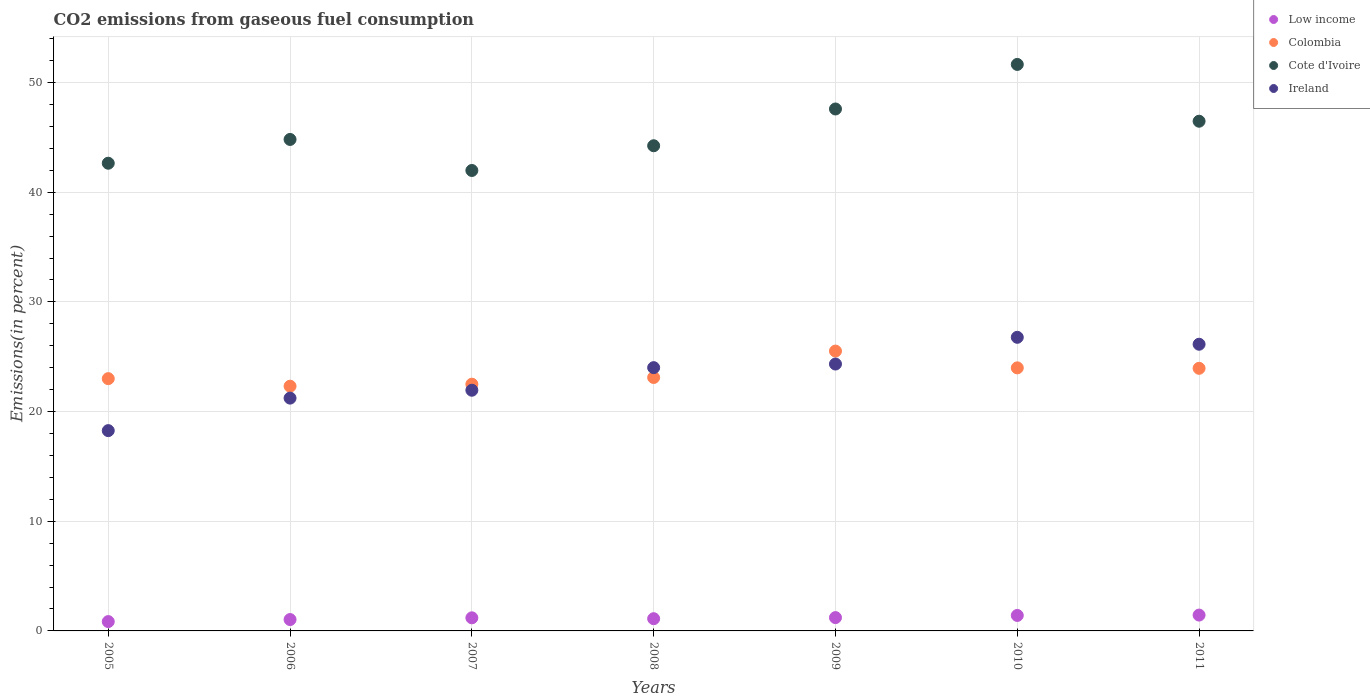How many different coloured dotlines are there?
Keep it short and to the point. 4. What is the total CO2 emitted in Cote d'Ivoire in 2007?
Keep it short and to the point. 41.98. Across all years, what is the maximum total CO2 emitted in Low income?
Make the answer very short. 1.44. Across all years, what is the minimum total CO2 emitted in Low income?
Your answer should be compact. 0.85. What is the total total CO2 emitted in Cote d'Ivoire in the graph?
Offer a terse response. 319.39. What is the difference between the total CO2 emitted in Low income in 2005 and that in 2011?
Your answer should be very brief. -0.59. What is the difference between the total CO2 emitted in Cote d'Ivoire in 2008 and the total CO2 emitted in Ireland in 2007?
Keep it short and to the point. 22.29. What is the average total CO2 emitted in Low income per year?
Keep it short and to the point. 1.18. In the year 2005, what is the difference between the total CO2 emitted in Cote d'Ivoire and total CO2 emitted in Ireland?
Provide a succinct answer. 24.38. What is the ratio of the total CO2 emitted in Low income in 2009 to that in 2011?
Your answer should be compact. 0.84. What is the difference between the highest and the second highest total CO2 emitted in Ireland?
Give a very brief answer. 0.63. What is the difference between the highest and the lowest total CO2 emitted in Cote d'Ivoire?
Your response must be concise. 9.67. Is it the case that in every year, the sum of the total CO2 emitted in Cote d'Ivoire and total CO2 emitted in Colombia  is greater than the sum of total CO2 emitted in Low income and total CO2 emitted in Ireland?
Offer a very short reply. Yes. Is it the case that in every year, the sum of the total CO2 emitted in Cote d'Ivoire and total CO2 emitted in Colombia  is greater than the total CO2 emitted in Low income?
Keep it short and to the point. Yes. Does the total CO2 emitted in Ireland monotonically increase over the years?
Make the answer very short. No. Is the total CO2 emitted in Colombia strictly greater than the total CO2 emitted in Ireland over the years?
Your answer should be compact. No. Is the total CO2 emitted in Colombia strictly less than the total CO2 emitted in Cote d'Ivoire over the years?
Offer a terse response. Yes. How many years are there in the graph?
Offer a terse response. 7. Does the graph contain grids?
Offer a terse response. Yes. How many legend labels are there?
Your answer should be compact. 4. How are the legend labels stacked?
Your answer should be compact. Vertical. What is the title of the graph?
Give a very brief answer. CO2 emissions from gaseous fuel consumption. What is the label or title of the X-axis?
Provide a short and direct response. Years. What is the label or title of the Y-axis?
Offer a terse response. Emissions(in percent). What is the Emissions(in percent) in Low income in 2005?
Offer a very short reply. 0.85. What is the Emissions(in percent) in Colombia in 2005?
Your response must be concise. 23. What is the Emissions(in percent) of Cote d'Ivoire in 2005?
Your response must be concise. 42.64. What is the Emissions(in percent) in Ireland in 2005?
Keep it short and to the point. 18.26. What is the Emissions(in percent) in Low income in 2006?
Provide a short and direct response. 1.04. What is the Emissions(in percent) of Colombia in 2006?
Provide a succinct answer. 22.31. What is the Emissions(in percent) in Cote d'Ivoire in 2006?
Offer a terse response. 44.81. What is the Emissions(in percent) of Ireland in 2006?
Offer a terse response. 21.23. What is the Emissions(in percent) of Low income in 2007?
Make the answer very short. 1.19. What is the Emissions(in percent) of Colombia in 2007?
Make the answer very short. 22.5. What is the Emissions(in percent) in Cote d'Ivoire in 2007?
Offer a very short reply. 41.98. What is the Emissions(in percent) in Ireland in 2007?
Give a very brief answer. 21.95. What is the Emissions(in percent) of Low income in 2008?
Give a very brief answer. 1.11. What is the Emissions(in percent) in Colombia in 2008?
Your response must be concise. 23.11. What is the Emissions(in percent) in Cote d'Ivoire in 2008?
Provide a succinct answer. 44.24. What is the Emissions(in percent) in Ireland in 2008?
Your response must be concise. 24.01. What is the Emissions(in percent) of Low income in 2009?
Offer a terse response. 1.21. What is the Emissions(in percent) of Colombia in 2009?
Provide a succinct answer. 25.52. What is the Emissions(in percent) of Cote d'Ivoire in 2009?
Make the answer very short. 47.59. What is the Emissions(in percent) of Ireland in 2009?
Provide a succinct answer. 24.33. What is the Emissions(in percent) in Low income in 2010?
Offer a very short reply. 1.41. What is the Emissions(in percent) in Colombia in 2010?
Make the answer very short. 23.99. What is the Emissions(in percent) of Cote d'Ivoire in 2010?
Make the answer very short. 51.65. What is the Emissions(in percent) of Ireland in 2010?
Give a very brief answer. 26.77. What is the Emissions(in percent) of Low income in 2011?
Your answer should be compact. 1.44. What is the Emissions(in percent) of Colombia in 2011?
Make the answer very short. 23.94. What is the Emissions(in percent) in Cote d'Ivoire in 2011?
Give a very brief answer. 46.47. What is the Emissions(in percent) of Ireland in 2011?
Keep it short and to the point. 26.14. Across all years, what is the maximum Emissions(in percent) of Low income?
Make the answer very short. 1.44. Across all years, what is the maximum Emissions(in percent) of Colombia?
Your response must be concise. 25.52. Across all years, what is the maximum Emissions(in percent) in Cote d'Ivoire?
Your response must be concise. 51.65. Across all years, what is the maximum Emissions(in percent) of Ireland?
Your answer should be very brief. 26.77. Across all years, what is the minimum Emissions(in percent) of Low income?
Provide a short and direct response. 0.85. Across all years, what is the minimum Emissions(in percent) in Colombia?
Make the answer very short. 22.31. Across all years, what is the minimum Emissions(in percent) of Cote d'Ivoire?
Give a very brief answer. 41.98. Across all years, what is the minimum Emissions(in percent) of Ireland?
Provide a short and direct response. 18.26. What is the total Emissions(in percent) in Low income in the graph?
Your answer should be compact. 8.27. What is the total Emissions(in percent) of Colombia in the graph?
Your response must be concise. 164.37. What is the total Emissions(in percent) in Cote d'Ivoire in the graph?
Offer a terse response. 319.39. What is the total Emissions(in percent) of Ireland in the graph?
Provide a short and direct response. 162.68. What is the difference between the Emissions(in percent) of Low income in 2005 and that in 2006?
Your answer should be very brief. -0.19. What is the difference between the Emissions(in percent) in Colombia in 2005 and that in 2006?
Provide a succinct answer. 0.69. What is the difference between the Emissions(in percent) in Cote d'Ivoire in 2005 and that in 2006?
Give a very brief answer. -2.17. What is the difference between the Emissions(in percent) of Ireland in 2005 and that in 2006?
Your response must be concise. -2.96. What is the difference between the Emissions(in percent) of Low income in 2005 and that in 2007?
Provide a succinct answer. -0.34. What is the difference between the Emissions(in percent) in Colombia in 2005 and that in 2007?
Offer a terse response. 0.51. What is the difference between the Emissions(in percent) of Cote d'Ivoire in 2005 and that in 2007?
Provide a short and direct response. 0.66. What is the difference between the Emissions(in percent) in Ireland in 2005 and that in 2007?
Provide a succinct answer. -3.68. What is the difference between the Emissions(in percent) in Low income in 2005 and that in 2008?
Your answer should be compact. -0.26. What is the difference between the Emissions(in percent) of Colombia in 2005 and that in 2008?
Make the answer very short. -0.11. What is the difference between the Emissions(in percent) in Cote d'Ivoire in 2005 and that in 2008?
Offer a very short reply. -1.59. What is the difference between the Emissions(in percent) in Ireland in 2005 and that in 2008?
Keep it short and to the point. -5.74. What is the difference between the Emissions(in percent) of Low income in 2005 and that in 2009?
Make the answer very short. -0.36. What is the difference between the Emissions(in percent) of Colombia in 2005 and that in 2009?
Your answer should be compact. -2.51. What is the difference between the Emissions(in percent) in Cote d'Ivoire in 2005 and that in 2009?
Your answer should be very brief. -4.95. What is the difference between the Emissions(in percent) of Ireland in 2005 and that in 2009?
Your answer should be very brief. -6.07. What is the difference between the Emissions(in percent) of Low income in 2005 and that in 2010?
Your answer should be very brief. -0.56. What is the difference between the Emissions(in percent) of Colombia in 2005 and that in 2010?
Your response must be concise. -0.98. What is the difference between the Emissions(in percent) in Cote d'Ivoire in 2005 and that in 2010?
Offer a very short reply. -9.01. What is the difference between the Emissions(in percent) in Ireland in 2005 and that in 2010?
Provide a succinct answer. -8.51. What is the difference between the Emissions(in percent) of Low income in 2005 and that in 2011?
Your answer should be compact. -0.59. What is the difference between the Emissions(in percent) in Colombia in 2005 and that in 2011?
Your response must be concise. -0.94. What is the difference between the Emissions(in percent) in Cote d'Ivoire in 2005 and that in 2011?
Your response must be concise. -3.83. What is the difference between the Emissions(in percent) in Ireland in 2005 and that in 2011?
Your answer should be very brief. -7.88. What is the difference between the Emissions(in percent) of Low income in 2006 and that in 2007?
Offer a terse response. -0.16. What is the difference between the Emissions(in percent) of Colombia in 2006 and that in 2007?
Offer a very short reply. -0.18. What is the difference between the Emissions(in percent) of Cote d'Ivoire in 2006 and that in 2007?
Keep it short and to the point. 2.83. What is the difference between the Emissions(in percent) in Ireland in 2006 and that in 2007?
Keep it short and to the point. -0.72. What is the difference between the Emissions(in percent) of Low income in 2006 and that in 2008?
Your answer should be very brief. -0.08. What is the difference between the Emissions(in percent) in Colombia in 2006 and that in 2008?
Provide a short and direct response. -0.79. What is the difference between the Emissions(in percent) of Cote d'Ivoire in 2006 and that in 2008?
Offer a very short reply. 0.57. What is the difference between the Emissions(in percent) of Ireland in 2006 and that in 2008?
Offer a very short reply. -2.78. What is the difference between the Emissions(in percent) in Low income in 2006 and that in 2009?
Keep it short and to the point. -0.18. What is the difference between the Emissions(in percent) of Colombia in 2006 and that in 2009?
Make the answer very short. -3.2. What is the difference between the Emissions(in percent) in Cote d'Ivoire in 2006 and that in 2009?
Provide a succinct answer. -2.78. What is the difference between the Emissions(in percent) in Ireland in 2006 and that in 2009?
Provide a succinct answer. -3.11. What is the difference between the Emissions(in percent) in Low income in 2006 and that in 2010?
Give a very brief answer. -0.37. What is the difference between the Emissions(in percent) of Colombia in 2006 and that in 2010?
Offer a very short reply. -1.67. What is the difference between the Emissions(in percent) of Cote d'Ivoire in 2006 and that in 2010?
Provide a short and direct response. -6.84. What is the difference between the Emissions(in percent) of Ireland in 2006 and that in 2010?
Offer a terse response. -5.54. What is the difference between the Emissions(in percent) of Low income in 2006 and that in 2011?
Your response must be concise. -0.41. What is the difference between the Emissions(in percent) of Colombia in 2006 and that in 2011?
Your response must be concise. -1.63. What is the difference between the Emissions(in percent) in Cote d'Ivoire in 2006 and that in 2011?
Provide a short and direct response. -1.66. What is the difference between the Emissions(in percent) of Ireland in 2006 and that in 2011?
Your response must be concise. -4.91. What is the difference between the Emissions(in percent) of Low income in 2007 and that in 2008?
Give a very brief answer. 0.08. What is the difference between the Emissions(in percent) in Colombia in 2007 and that in 2008?
Give a very brief answer. -0.61. What is the difference between the Emissions(in percent) of Cote d'Ivoire in 2007 and that in 2008?
Your response must be concise. -2.25. What is the difference between the Emissions(in percent) of Ireland in 2007 and that in 2008?
Give a very brief answer. -2.06. What is the difference between the Emissions(in percent) of Low income in 2007 and that in 2009?
Your response must be concise. -0.02. What is the difference between the Emissions(in percent) of Colombia in 2007 and that in 2009?
Keep it short and to the point. -3.02. What is the difference between the Emissions(in percent) in Cote d'Ivoire in 2007 and that in 2009?
Provide a succinct answer. -5.61. What is the difference between the Emissions(in percent) of Ireland in 2007 and that in 2009?
Provide a short and direct response. -2.39. What is the difference between the Emissions(in percent) in Low income in 2007 and that in 2010?
Make the answer very short. -0.22. What is the difference between the Emissions(in percent) of Colombia in 2007 and that in 2010?
Your response must be concise. -1.49. What is the difference between the Emissions(in percent) of Cote d'Ivoire in 2007 and that in 2010?
Your response must be concise. -9.67. What is the difference between the Emissions(in percent) in Ireland in 2007 and that in 2010?
Offer a terse response. -4.83. What is the difference between the Emissions(in percent) in Low income in 2007 and that in 2011?
Provide a succinct answer. -0.25. What is the difference between the Emissions(in percent) in Colombia in 2007 and that in 2011?
Make the answer very short. -1.45. What is the difference between the Emissions(in percent) in Cote d'Ivoire in 2007 and that in 2011?
Make the answer very short. -4.49. What is the difference between the Emissions(in percent) of Ireland in 2007 and that in 2011?
Offer a terse response. -4.19. What is the difference between the Emissions(in percent) in Low income in 2008 and that in 2009?
Your answer should be very brief. -0.1. What is the difference between the Emissions(in percent) of Colombia in 2008 and that in 2009?
Keep it short and to the point. -2.41. What is the difference between the Emissions(in percent) of Cote d'Ivoire in 2008 and that in 2009?
Provide a succinct answer. -3.35. What is the difference between the Emissions(in percent) of Ireland in 2008 and that in 2009?
Offer a very short reply. -0.33. What is the difference between the Emissions(in percent) in Low income in 2008 and that in 2010?
Your answer should be compact. -0.3. What is the difference between the Emissions(in percent) of Colombia in 2008 and that in 2010?
Ensure brevity in your answer.  -0.88. What is the difference between the Emissions(in percent) in Cote d'Ivoire in 2008 and that in 2010?
Provide a succinct answer. -7.41. What is the difference between the Emissions(in percent) in Ireland in 2008 and that in 2010?
Your answer should be very brief. -2.77. What is the difference between the Emissions(in percent) of Low income in 2008 and that in 2011?
Make the answer very short. -0.33. What is the difference between the Emissions(in percent) of Colombia in 2008 and that in 2011?
Offer a very short reply. -0.84. What is the difference between the Emissions(in percent) of Cote d'Ivoire in 2008 and that in 2011?
Give a very brief answer. -2.24. What is the difference between the Emissions(in percent) of Ireland in 2008 and that in 2011?
Offer a terse response. -2.13. What is the difference between the Emissions(in percent) in Low income in 2009 and that in 2010?
Provide a succinct answer. -0.2. What is the difference between the Emissions(in percent) in Colombia in 2009 and that in 2010?
Offer a very short reply. 1.53. What is the difference between the Emissions(in percent) of Cote d'Ivoire in 2009 and that in 2010?
Your response must be concise. -4.06. What is the difference between the Emissions(in percent) in Ireland in 2009 and that in 2010?
Ensure brevity in your answer.  -2.44. What is the difference between the Emissions(in percent) in Low income in 2009 and that in 2011?
Keep it short and to the point. -0.23. What is the difference between the Emissions(in percent) of Colombia in 2009 and that in 2011?
Ensure brevity in your answer.  1.57. What is the difference between the Emissions(in percent) of Cote d'Ivoire in 2009 and that in 2011?
Offer a very short reply. 1.12. What is the difference between the Emissions(in percent) of Ireland in 2009 and that in 2011?
Offer a very short reply. -1.8. What is the difference between the Emissions(in percent) of Low income in 2010 and that in 2011?
Keep it short and to the point. -0.03. What is the difference between the Emissions(in percent) of Colombia in 2010 and that in 2011?
Give a very brief answer. 0.04. What is the difference between the Emissions(in percent) of Cote d'Ivoire in 2010 and that in 2011?
Your answer should be compact. 5.18. What is the difference between the Emissions(in percent) in Ireland in 2010 and that in 2011?
Ensure brevity in your answer.  0.63. What is the difference between the Emissions(in percent) of Low income in 2005 and the Emissions(in percent) of Colombia in 2006?
Your response must be concise. -21.46. What is the difference between the Emissions(in percent) of Low income in 2005 and the Emissions(in percent) of Cote d'Ivoire in 2006?
Your answer should be very brief. -43.96. What is the difference between the Emissions(in percent) of Low income in 2005 and the Emissions(in percent) of Ireland in 2006?
Give a very brief answer. -20.38. What is the difference between the Emissions(in percent) of Colombia in 2005 and the Emissions(in percent) of Cote d'Ivoire in 2006?
Ensure brevity in your answer.  -21.81. What is the difference between the Emissions(in percent) of Colombia in 2005 and the Emissions(in percent) of Ireland in 2006?
Your answer should be very brief. 1.78. What is the difference between the Emissions(in percent) in Cote d'Ivoire in 2005 and the Emissions(in percent) in Ireland in 2006?
Make the answer very short. 21.42. What is the difference between the Emissions(in percent) in Low income in 2005 and the Emissions(in percent) in Colombia in 2007?
Give a very brief answer. -21.65. What is the difference between the Emissions(in percent) of Low income in 2005 and the Emissions(in percent) of Cote d'Ivoire in 2007?
Your answer should be very brief. -41.13. What is the difference between the Emissions(in percent) in Low income in 2005 and the Emissions(in percent) in Ireland in 2007?
Your answer should be compact. -21.09. What is the difference between the Emissions(in percent) of Colombia in 2005 and the Emissions(in percent) of Cote d'Ivoire in 2007?
Provide a succinct answer. -18.98. What is the difference between the Emissions(in percent) of Colombia in 2005 and the Emissions(in percent) of Ireland in 2007?
Your answer should be compact. 1.06. What is the difference between the Emissions(in percent) in Cote d'Ivoire in 2005 and the Emissions(in percent) in Ireland in 2007?
Provide a succinct answer. 20.7. What is the difference between the Emissions(in percent) in Low income in 2005 and the Emissions(in percent) in Colombia in 2008?
Offer a terse response. -22.26. What is the difference between the Emissions(in percent) in Low income in 2005 and the Emissions(in percent) in Cote d'Ivoire in 2008?
Ensure brevity in your answer.  -43.39. What is the difference between the Emissions(in percent) of Low income in 2005 and the Emissions(in percent) of Ireland in 2008?
Ensure brevity in your answer.  -23.15. What is the difference between the Emissions(in percent) of Colombia in 2005 and the Emissions(in percent) of Cote d'Ivoire in 2008?
Your answer should be compact. -21.23. What is the difference between the Emissions(in percent) of Colombia in 2005 and the Emissions(in percent) of Ireland in 2008?
Offer a terse response. -1. What is the difference between the Emissions(in percent) in Cote d'Ivoire in 2005 and the Emissions(in percent) in Ireland in 2008?
Keep it short and to the point. 18.64. What is the difference between the Emissions(in percent) in Low income in 2005 and the Emissions(in percent) in Colombia in 2009?
Provide a succinct answer. -24.66. What is the difference between the Emissions(in percent) of Low income in 2005 and the Emissions(in percent) of Cote d'Ivoire in 2009?
Your answer should be very brief. -46.74. What is the difference between the Emissions(in percent) of Low income in 2005 and the Emissions(in percent) of Ireland in 2009?
Your answer should be very brief. -23.48. What is the difference between the Emissions(in percent) of Colombia in 2005 and the Emissions(in percent) of Cote d'Ivoire in 2009?
Your answer should be compact. -24.59. What is the difference between the Emissions(in percent) of Colombia in 2005 and the Emissions(in percent) of Ireland in 2009?
Keep it short and to the point. -1.33. What is the difference between the Emissions(in percent) in Cote d'Ivoire in 2005 and the Emissions(in percent) in Ireland in 2009?
Give a very brief answer. 18.31. What is the difference between the Emissions(in percent) of Low income in 2005 and the Emissions(in percent) of Colombia in 2010?
Your answer should be very brief. -23.13. What is the difference between the Emissions(in percent) in Low income in 2005 and the Emissions(in percent) in Cote d'Ivoire in 2010?
Offer a very short reply. -50.8. What is the difference between the Emissions(in percent) of Low income in 2005 and the Emissions(in percent) of Ireland in 2010?
Your response must be concise. -25.92. What is the difference between the Emissions(in percent) in Colombia in 2005 and the Emissions(in percent) in Cote d'Ivoire in 2010?
Your answer should be very brief. -28.65. What is the difference between the Emissions(in percent) of Colombia in 2005 and the Emissions(in percent) of Ireland in 2010?
Ensure brevity in your answer.  -3.77. What is the difference between the Emissions(in percent) of Cote d'Ivoire in 2005 and the Emissions(in percent) of Ireland in 2010?
Ensure brevity in your answer.  15.87. What is the difference between the Emissions(in percent) of Low income in 2005 and the Emissions(in percent) of Colombia in 2011?
Keep it short and to the point. -23.09. What is the difference between the Emissions(in percent) in Low income in 2005 and the Emissions(in percent) in Cote d'Ivoire in 2011?
Provide a short and direct response. -45.62. What is the difference between the Emissions(in percent) of Low income in 2005 and the Emissions(in percent) of Ireland in 2011?
Offer a very short reply. -25.29. What is the difference between the Emissions(in percent) in Colombia in 2005 and the Emissions(in percent) in Cote d'Ivoire in 2011?
Offer a terse response. -23.47. What is the difference between the Emissions(in percent) of Colombia in 2005 and the Emissions(in percent) of Ireland in 2011?
Your answer should be compact. -3.14. What is the difference between the Emissions(in percent) of Cote d'Ivoire in 2005 and the Emissions(in percent) of Ireland in 2011?
Make the answer very short. 16.5. What is the difference between the Emissions(in percent) in Low income in 2006 and the Emissions(in percent) in Colombia in 2007?
Offer a very short reply. -21.46. What is the difference between the Emissions(in percent) of Low income in 2006 and the Emissions(in percent) of Cote d'Ivoire in 2007?
Make the answer very short. -40.94. What is the difference between the Emissions(in percent) in Low income in 2006 and the Emissions(in percent) in Ireland in 2007?
Keep it short and to the point. -20.91. What is the difference between the Emissions(in percent) of Colombia in 2006 and the Emissions(in percent) of Cote d'Ivoire in 2007?
Your response must be concise. -19.67. What is the difference between the Emissions(in percent) in Colombia in 2006 and the Emissions(in percent) in Ireland in 2007?
Give a very brief answer. 0.37. What is the difference between the Emissions(in percent) of Cote d'Ivoire in 2006 and the Emissions(in percent) of Ireland in 2007?
Give a very brief answer. 22.87. What is the difference between the Emissions(in percent) in Low income in 2006 and the Emissions(in percent) in Colombia in 2008?
Your answer should be very brief. -22.07. What is the difference between the Emissions(in percent) in Low income in 2006 and the Emissions(in percent) in Cote d'Ivoire in 2008?
Give a very brief answer. -43.2. What is the difference between the Emissions(in percent) of Low income in 2006 and the Emissions(in percent) of Ireland in 2008?
Provide a succinct answer. -22.97. What is the difference between the Emissions(in percent) of Colombia in 2006 and the Emissions(in percent) of Cote d'Ivoire in 2008?
Your response must be concise. -21.92. What is the difference between the Emissions(in percent) of Colombia in 2006 and the Emissions(in percent) of Ireland in 2008?
Provide a short and direct response. -1.69. What is the difference between the Emissions(in percent) in Cote d'Ivoire in 2006 and the Emissions(in percent) in Ireland in 2008?
Provide a succinct answer. 20.81. What is the difference between the Emissions(in percent) of Low income in 2006 and the Emissions(in percent) of Colombia in 2009?
Make the answer very short. -24.48. What is the difference between the Emissions(in percent) in Low income in 2006 and the Emissions(in percent) in Cote d'Ivoire in 2009?
Give a very brief answer. -46.55. What is the difference between the Emissions(in percent) of Low income in 2006 and the Emissions(in percent) of Ireland in 2009?
Keep it short and to the point. -23.3. What is the difference between the Emissions(in percent) of Colombia in 2006 and the Emissions(in percent) of Cote d'Ivoire in 2009?
Provide a short and direct response. -25.28. What is the difference between the Emissions(in percent) in Colombia in 2006 and the Emissions(in percent) in Ireland in 2009?
Provide a succinct answer. -2.02. What is the difference between the Emissions(in percent) in Cote d'Ivoire in 2006 and the Emissions(in percent) in Ireland in 2009?
Offer a very short reply. 20.48. What is the difference between the Emissions(in percent) of Low income in 2006 and the Emissions(in percent) of Colombia in 2010?
Provide a succinct answer. -22.95. What is the difference between the Emissions(in percent) of Low income in 2006 and the Emissions(in percent) of Cote d'Ivoire in 2010?
Make the answer very short. -50.61. What is the difference between the Emissions(in percent) in Low income in 2006 and the Emissions(in percent) in Ireland in 2010?
Your response must be concise. -25.73. What is the difference between the Emissions(in percent) in Colombia in 2006 and the Emissions(in percent) in Cote d'Ivoire in 2010?
Provide a succinct answer. -29.34. What is the difference between the Emissions(in percent) in Colombia in 2006 and the Emissions(in percent) in Ireland in 2010?
Provide a short and direct response. -4.46. What is the difference between the Emissions(in percent) of Cote d'Ivoire in 2006 and the Emissions(in percent) of Ireland in 2010?
Offer a terse response. 18.04. What is the difference between the Emissions(in percent) in Low income in 2006 and the Emissions(in percent) in Colombia in 2011?
Your answer should be compact. -22.91. What is the difference between the Emissions(in percent) in Low income in 2006 and the Emissions(in percent) in Cote d'Ivoire in 2011?
Ensure brevity in your answer.  -45.44. What is the difference between the Emissions(in percent) of Low income in 2006 and the Emissions(in percent) of Ireland in 2011?
Keep it short and to the point. -25.1. What is the difference between the Emissions(in percent) in Colombia in 2006 and the Emissions(in percent) in Cote d'Ivoire in 2011?
Ensure brevity in your answer.  -24.16. What is the difference between the Emissions(in percent) of Colombia in 2006 and the Emissions(in percent) of Ireland in 2011?
Keep it short and to the point. -3.82. What is the difference between the Emissions(in percent) of Cote d'Ivoire in 2006 and the Emissions(in percent) of Ireland in 2011?
Your answer should be very brief. 18.67. What is the difference between the Emissions(in percent) of Low income in 2007 and the Emissions(in percent) of Colombia in 2008?
Keep it short and to the point. -21.91. What is the difference between the Emissions(in percent) in Low income in 2007 and the Emissions(in percent) in Cote d'Ivoire in 2008?
Offer a very short reply. -43.04. What is the difference between the Emissions(in percent) of Low income in 2007 and the Emissions(in percent) of Ireland in 2008?
Provide a short and direct response. -22.81. What is the difference between the Emissions(in percent) in Colombia in 2007 and the Emissions(in percent) in Cote d'Ivoire in 2008?
Make the answer very short. -21.74. What is the difference between the Emissions(in percent) of Colombia in 2007 and the Emissions(in percent) of Ireland in 2008?
Your answer should be very brief. -1.51. What is the difference between the Emissions(in percent) in Cote d'Ivoire in 2007 and the Emissions(in percent) in Ireland in 2008?
Your response must be concise. 17.98. What is the difference between the Emissions(in percent) in Low income in 2007 and the Emissions(in percent) in Colombia in 2009?
Make the answer very short. -24.32. What is the difference between the Emissions(in percent) of Low income in 2007 and the Emissions(in percent) of Cote d'Ivoire in 2009?
Provide a succinct answer. -46.4. What is the difference between the Emissions(in percent) of Low income in 2007 and the Emissions(in percent) of Ireland in 2009?
Make the answer very short. -23.14. What is the difference between the Emissions(in percent) of Colombia in 2007 and the Emissions(in percent) of Cote d'Ivoire in 2009?
Ensure brevity in your answer.  -25.09. What is the difference between the Emissions(in percent) of Colombia in 2007 and the Emissions(in percent) of Ireland in 2009?
Ensure brevity in your answer.  -1.84. What is the difference between the Emissions(in percent) in Cote d'Ivoire in 2007 and the Emissions(in percent) in Ireland in 2009?
Your response must be concise. 17.65. What is the difference between the Emissions(in percent) in Low income in 2007 and the Emissions(in percent) in Colombia in 2010?
Ensure brevity in your answer.  -22.79. What is the difference between the Emissions(in percent) in Low income in 2007 and the Emissions(in percent) in Cote d'Ivoire in 2010?
Ensure brevity in your answer.  -50.46. What is the difference between the Emissions(in percent) of Low income in 2007 and the Emissions(in percent) of Ireland in 2010?
Provide a short and direct response. -25.58. What is the difference between the Emissions(in percent) in Colombia in 2007 and the Emissions(in percent) in Cote d'Ivoire in 2010?
Your answer should be compact. -29.15. What is the difference between the Emissions(in percent) of Colombia in 2007 and the Emissions(in percent) of Ireland in 2010?
Provide a short and direct response. -4.27. What is the difference between the Emissions(in percent) of Cote d'Ivoire in 2007 and the Emissions(in percent) of Ireland in 2010?
Keep it short and to the point. 15.21. What is the difference between the Emissions(in percent) of Low income in 2007 and the Emissions(in percent) of Colombia in 2011?
Your response must be concise. -22.75. What is the difference between the Emissions(in percent) of Low income in 2007 and the Emissions(in percent) of Cote d'Ivoire in 2011?
Provide a short and direct response. -45.28. What is the difference between the Emissions(in percent) in Low income in 2007 and the Emissions(in percent) in Ireland in 2011?
Make the answer very short. -24.94. What is the difference between the Emissions(in percent) in Colombia in 2007 and the Emissions(in percent) in Cote d'Ivoire in 2011?
Your response must be concise. -23.98. What is the difference between the Emissions(in percent) of Colombia in 2007 and the Emissions(in percent) of Ireland in 2011?
Your response must be concise. -3.64. What is the difference between the Emissions(in percent) of Cote d'Ivoire in 2007 and the Emissions(in percent) of Ireland in 2011?
Provide a succinct answer. 15.84. What is the difference between the Emissions(in percent) in Low income in 2008 and the Emissions(in percent) in Colombia in 2009?
Provide a succinct answer. -24.4. What is the difference between the Emissions(in percent) of Low income in 2008 and the Emissions(in percent) of Cote d'Ivoire in 2009?
Give a very brief answer. -46.47. What is the difference between the Emissions(in percent) in Low income in 2008 and the Emissions(in percent) in Ireland in 2009?
Your response must be concise. -23.22. What is the difference between the Emissions(in percent) in Colombia in 2008 and the Emissions(in percent) in Cote d'Ivoire in 2009?
Offer a very short reply. -24.48. What is the difference between the Emissions(in percent) of Colombia in 2008 and the Emissions(in percent) of Ireland in 2009?
Your answer should be compact. -1.23. What is the difference between the Emissions(in percent) in Cote d'Ivoire in 2008 and the Emissions(in percent) in Ireland in 2009?
Your answer should be compact. 19.9. What is the difference between the Emissions(in percent) in Low income in 2008 and the Emissions(in percent) in Colombia in 2010?
Give a very brief answer. -22.87. What is the difference between the Emissions(in percent) of Low income in 2008 and the Emissions(in percent) of Cote d'Ivoire in 2010?
Provide a short and direct response. -50.54. What is the difference between the Emissions(in percent) of Low income in 2008 and the Emissions(in percent) of Ireland in 2010?
Provide a short and direct response. -25.66. What is the difference between the Emissions(in percent) in Colombia in 2008 and the Emissions(in percent) in Cote d'Ivoire in 2010?
Your answer should be compact. -28.54. What is the difference between the Emissions(in percent) of Colombia in 2008 and the Emissions(in percent) of Ireland in 2010?
Give a very brief answer. -3.66. What is the difference between the Emissions(in percent) of Cote d'Ivoire in 2008 and the Emissions(in percent) of Ireland in 2010?
Give a very brief answer. 17.47. What is the difference between the Emissions(in percent) in Low income in 2008 and the Emissions(in percent) in Colombia in 2011?
Offer a terse response. -22.83. What is the difference between the Emissions(in percent) in Low income in 2008 and the Emissions(in percent) in Cote d'Ivoire in 2011?
Offer a very short reply. -45.36. What is the difference between the Emissions(in percent) in Low income in 2008 and the Emissions(in percent) in Ireland in 2011?
Provide a succinct answer. -25.02. What is the difference between the Emissions(in percent) in Colombia in 2008 and the Emissions(in percent) in Cote d'Ivoire in 2011?
Make the answer very short. -23.37. What is the difference between the Emissions(in percent) of Colombia in 2008 and the Emissions(in percent) of Ireland in 2011?
Provide a succinct answer. -3.03. What is the difference between the Emissions(in percent) of Cote d'Ivoire in 2008 and the Emissions(in percent) of Ireland in 2011?
Provide a succinct answer. 18.1. What is the difference between the Emissions(in percent) in Low income in 2009 and the Emissions(in percent) in Colombia in 2010?
Make the answer very short. -22.77. What is the difference between the Emissions(in percent) of Low income in 2009 and the Emissions(in percent) of Cote d'Ivoire in 2010?
Your response must be concise. -50.44. What is the difference between the Emissions(in percent) of Low income in 2009 and the Emissions(in percent) of Ireland in 2010?
Offer a terse response. -25.56. What is the difference between the Emissions(in percent) in Colombia in 2009 and the Emissions(in percent) in Cote d'Ivoire in 2010?
Your answer should be very brief. -26.14. What is the difference between the Emissions(in percent) of Colombia in 2009 and the Emissions(in percent) of Ireland in 2010?
Your answer should be compact. -1.26. What is the difference between the Emissions(in percent) of Cote d'Ivoire in 2009 and the Emissions(in percent) of Ireland in 2010?
Offer a terse response. 20.82. What is the difference between the Emissions(in percent) of Low income in 2009 and the Emissions(in percent) of Colombia in 2011?
Ensure brevity in your answer.  -22.73. What is the difference between the Emissions(in percent) in Low income in 2009 and the Emissions(in percent) in Cote d'Ivoire in 2011?
Keep it short and to the point. -45.26. What is the difference between the Emissions(in percent) in Low income in 2009 and the Emissions(in percent) in Ireland in 2011?
Your response must be concise. -24.92. What is the difference between the Emissions(in percent) in Colombia in 2009 and the Emissions(in percent) in Cote d'Ivoire in 2011?
Your answer should be very brief. -20.96. What is the difference between the Emissions(in percent) of Colombia in 2009 and the Emissions(in percent) of Ireland in 2011?
Offer a very short reply. -0.62. What is the difference between the Emissions(in percent) in Cote d'Ivoire in 2009 and the Emissions(in percent) in Ireland in 2011?
Your answer should be very brief. 21.45. What is the difference between the Emissions(in percent) in Low income in 2010 and the Emissions(in percent) in Colombia in 2011?
Make the answer very short. -22.53. What is the difference between the Emissions(in percent) in Low income in 2010 and the Emissions(in percent) in Cote d'Ivoire in 2011?
Your answer should be very brief. -45.06. What is the difference between the Emissions(in percent) of Low income in 2010 and the Emissions(in percent) of Ireland in 2011?
Give a very brief answer. -24.73. What is the difference between the Emissions(in percent) in Colombia in 2010 and the Emissions(in percent) in Cote d'Ivoire in 2011?
Your response must be concise. -22.49. What is the difference between the Emissions(in percent) of Colombia in 2010 and the Emissions(in percent) of Ireland in 2011?
Provide a succinct answer. -2.15. What is the difference between the Emissions(in percent) in Cote d'Ivoire in 2010 and the Emissions(in percent) in Ireland in 2011?
Offer a terse response. 25.51. What is the average Emissions(in percent) in Low income per year?
Ensure brevity in your answer.  1.18. What is the average Emissions(in percent) in Colombia per year?
Provide a short and direct response. 23.48. What is the average Emissions(in percent) of Cote d'Ivoire per year?
Give a very brief answer. 45.63. What is the average Emissions(in percent) in Ireland per year?
Ensure brevity in your answer.  23.24. In the year 2005, what is the difference between the Emissions(in percent) in Low income and Emissions(in percent) in Colombia?
Give a very brief answer. -22.15. In the year 2005, what is the difference between the Emissions(in percent) in Low income and Emissions(in percent) in Cote d'Ivoire?
Your answer should be very brief. -41.79. In the year 2005, what is the difference between the Emissions(in percent) in Low income and Emissions(in percent) in Ireland?
Provide a short and direct response. -17.41. In the year 2005, what is the difference between the Emissions(in percent) of Colombia and Emissions(in percent) of Cote d'Ivoire?
Provide a succinct answer. -19.64. In the year 2005, what is the difference between the Emissions(in percent) in Colombia and Emissions(in percent) in Ireland?
Offer a very short reply. 4.74. In the year 2005, what is the difference between the Emissions(in percent) in Cote d'Ivoire and Emissions(in percent) in Ireland?
Give a very brief answer. 24.38. In the year 2006, what is the difference between the Emissions(in percent) in Low income and Emissions(in percent) in Colombia?
Your response must be concise. -21.28. In the year 2006, what is the difference between the Emissions(in percent) of Low income and Emissions(in percent) of Cote d'Ivoire?
Ensure brevity in your answer.  -43.77. In the year 2006, what is the difference between the Emissions(in percent) of Low income and Emissions(in percent) of Ireland?
Offer a very short reply. -20.19. In the year 2006, what is the difference between the Emissions(in percent) of Colombia and Emissions(in percent) of Cote d'Ivoire?
Give a very brief answer. -22.5. In the year 2006, what is the difference between the Emissions(in percent) in Colombia and Emissions(in percent) in Ireland?
Offer a terse response. 1.09. In the year 2006, what is the difference between the Emissions(in percent) of Cote d'Ivoire and Emissions(in percent) of Ireland?
Your answer should be very brief. 23.58. In the year 2007, what is the difference between the Emissions(in percent) of Low income and Emissions(in percent) of Colombia?
Make the answer very short. -21.3. In the year 2007, what is the difference between the Emissions(in percent) in Low income and Emissions(in percent) in Cote d'Ivoire?
Your response must be concise. -40.79. In the year 2007, what is the difference between the Emissions(in percent) of Low income and Emissions(in percent) of Ireland?
Your answer should be compact. -20.75. In the year 2007, what is the difference between the Emissions(in percent) in Colombia and Emissions(in percent) in Cote d'Ivoire?
Give a very brief answer. -19.49. In the year 2007, what is the difference between the Emissions(in percent) in Colombia and Emissions(in percent) in Ireland?
Your answer should be very brief. 0.55. In the year 2007, what is the difference between the Emissions(in percent) of Cote d'Ivoire and Emissions(in percent) of Ireland?
Make the answer very short. 20.04. In the year 2008, what is the difference between the Emissions(in percent) in Low income and Emissions(in percent) in Colombia?
Make the answer very short. -21.99. In the year 2008, what is the difference between the Emissions(in percent) of Low income and Emissions(in percent) of Cote d'Ivoire?
Your response must be concise. -43.12. In the year 2008, what is the difference between the Emissions(in percent) of Low income and Emissions(in percent) of Ireland?
Offer a very short reply. -22.89. In the year 2008, what is the difference between the Emissions(in percent) in Colombia and Emissions(in percent) in Cote d'Ivoire?
Provide a short and direct response. -21.13. In the year 2008, what is the difference between the Emissions(in percent) of Colombia and Emissions(in percent) of Ireland?
Your answer should be compact. -0.9. In the year 2008, what is the difference between the Emissions(in percent) in Cote d'Ivoire and Emissions(in percent) in Ireland?
Give a very brief answer. 20.23. In the year 2009, what is the difference between the Emissions(in percent) in Low income and Emissions(in percent) in Colombia?
Your answer should be very brief. -24.3. In the year 2009, what is the difference between the Emissions(in percent) of Low income and Emissions(in percent) of Cote d'Ivoire?
Make the answer very short. -46.37. In the year 2009, what is the difference between the Emissions(in percent) in Low income and Emissions(in percent) in Ireland?
Provide a succinct answer. -23.12. In the year 2009, what is the difference between the Emissions(in percent) in Colombia and Emissions(in percent) in Cote d'Ivoire?
Your answer should be compact. -22.07. In the year 2009, what is the difference between the Emissions(in percent) of Colombia and Emissions(in percent) of Ireland?
Give a very brief answer. 1.18. In the year 2009, what is the difference between the Emissions(in percent) of Cote d'Ivoire and Emissions(in percent) of Ireland?
Make the answer very short. 23.26. In the year 2010, what is the difference between the Emissions(in percent) of Low income and Emissions(in percent) of Colombia?
Ensure brevity in your answer.  -22.57. In the year 2010, what is the difference between the Emissions(in percent) of Low income and Emissions(in percent) of Cote d'Ivoire?
Provide a succinct answer. -50.24. In the year 2010, what is the difference between the Emissions(in percent) in Low income and Emissions(in percent) in Ireland?
Ensure brevity in your answer.  -25.36. In the year 2010, what is the difference between the Emissions(in percent) in Colombia and Emissions(in percent) in Cote d'Ivoire?
Your answer should be very brief. -27.67. In the year 2010, what is the difference between the Emissions(in percent) in Colombia and Emissions(in percent) in Ireland?
Offer a very short reply. -2.79. In the year 2010, what is the difference between the Emissions(in percent) of Cote d'Ivoire and Emissions(in percent) of Ireland?
Make the answer very short. 24.88. In the year 2011, what is the difference between the Emissions(in percent) of Low income and Emissions(in percent) of Colombia?
Make the answer very short. -22.5. In the year 2011, what is the difference between the Emissions(in percent) of Low income and Emissions(in percent) of Cote d'Ivoire?
Provide a succinct answer. -45.03. In the year 2011, what is the difference between the Emissions(in percent) in Low income and Emissions(in percent) in Ireland?
Your answer should be very brief. -24.69. In the year 2011, what is the difference between the Emissions(in percent) in Colombia and Emissions(in percent) in Cote d'Ivoire?
Make the answer very short. -22.53. In the year 2011, what is the difference between the Emissions(in percent) of Colombia and Emissions(in percent) of Ireland?
Keep it short and to the point. -2.19. In the year 2011, what is the difference between the Emissions(in percent) of Cote d'Ivoire and Emissions(in percent) of Ireland?
Provide a succinct answer. 20.33. What is the ratio of the Emissions(in percent) in Low income in 2005 to that in 2006?
Offer a very short reply. 0.82. What is the ratio of the Emissions(in percent) of Colombia in 2005 to that in 2006?
Ensure brevity in your answer.  1.03. What is the ratio of the Emissions(in percent) of Cote d'Ivoire in 2005 to that in 2006?
Offer a terse response. 0.95. What is the ratio of the Emissions(in percent) of Ireland in 2005 to that in 2006?
Give a very brief answer. 0.86. What is the ratio of the Emissions(in percent) in Low income in 2005 to that in 2007?
Keep it short and to the point. 0.71. What is the ratio of the Emissions(in percent) in Colombia in 2005 to that in 2007?
Offer a very short reply. 1.02. What is the ratio of the Emissions(in percent) in Cote d'Ivoire in 2005 to that in 2007?
Ensure brevity in your answer.  1.02. What is the ratio of the Emissions(in percent) in Ireland in 2005 to that in 2007?
Your response must be concise. 0.83. What is the ratio of the Emissions(in percent) in Low income in 2005 to that in 2008?
Provide a short and direct response. 0.76. What is the ratio of the Emissions(in percent) in Colombia in 2005 to that in 2008?
Your response must be concise. 1. What is the ratio of the Emissions(in percent) in Cote d'Ivoire in 2005 to that in 2008?
Ensure brevity in your answer.  0.96. What is the ratio of the Emissions(in percent) of Ireland in 2005 to that in 2008?
Your answer should be very brief. 0.76. What is the ratio of the Emissions(in percent) in Low income in 2005 to that in 2009?
Your answer should be very brief. 0.7. What is the ratio of the Emissions(in percent) of Colombia in 2005 to that in 2009?
Offer a terse response. 0.9. What is the ratio of the Emissions(in percent) of Cote d'Ivoire in 2005 to that in 2009?
Offer a terse response. 0.9. What is the ratio of the Emissions(in percent) of Ireland in 2005 to that in 2009?
Provide a succinct answer. 0.75. What is the ratio of the Emissions(in percent) in Low income in 2005 to that in 2010?
Offer a terse response. 0.6. What is the ratio of the Emissions(in percent) of Colombia in 2005 to that in 2010?
Ensure brevity in your answer.  0.96. What is the ratio of the Emissions(in percent) of Cote d'Ivoire in 2005 to that in 2010?
Offer a terse response. 0.83. What is the ratio of the Emissions(in percent) of Ireland in 2005 to that in 2010?
Provide a short and direct response. 0.68. What is the ratio of the Emissions(in percent) in Low income in 2005 to that in 2011?
Your answer should be very brief. 0.59. What is the ratio of the Emissions(in percent) in Colombia in 2005 to that in 2011?
Your answer should be compact. 0.96. What is the ratio of the Emissions(in percent) in Cote d'Ivoire in 2005 to that in 2011?
Keep it short and to the point. 0.92. What is the ratio of the Emissions(in percent) of Ireland in 2005 to that in 2011?
Give a very brief answer. 0.7. What is the ratio of the Emissions(in percent) of Low income in 2006 to that in 2007?
Offer a very short reply. 0.87. What is the ratio of the Emissions(in percent) in Cote d'Ivoire in 2006 to that in 2007?
Your answer should be compact. 1.07. What is the ratio of the Emissions(in percent) of Ireland in 2006 to that in 2007?
Offer a very short reply. 0.97. What is the ratio of the Emissions(in percent) of Low income in 2006 to that in 2008?
Give a very brief answer. 0.93. What is the ratio of the Emissions(in percent) of Colombia in 2006 to that in 2008?
Offer a very short reply. 0.97. What is the ratio of the Emissions(in percent) of Ireland in 2006 to that in 2008?
Keep it short and to the point. 0.88. What is the ratio of the Emissions(in percent) in Low income in 2006 to that in 2009?
Ensure brevity in your answer.  0.85. What is the ratio of the Emissions(in percent) of Colombia in 2006 to that in 2009?
Your response must be concise. 0.87. What is the ratio of the Emissions(in percent) in Cote d'Ivoire in 2006 to that in 2009?
Your answer should be compact. 0.94. What is the ratio of the Emissions(in percent) of Ireland in 2006 to that in 2009?
Your response must be concise. 0.87. What is the ratio of the Emissions(in percent) of Low income in 2006 to that in 2010?
Make the answer very short. 0.74. What is the ratio of the Emissions(in percent) of Colombia in 2006 to that in 2010?
Make the answer very short. 0.93. What is the ratio of the Emissions(in percent) in Cote d'Ivoire in 2006 to that in 2010?
Provide a succinct answer. 0.87. What is the ratio of the Emissions(in percent) of Ireland in 2006 to that in 2010?
Give a very brief answer. 0.79. What is the ratio of the Emissions(in percent) of Low income in 2006 to that in 2011?
Offer a terse response. 0.72. What is the ratio of the Emissions(in percent) of Colombia in 2006 to that in 2011?
Your answer should be very brief. 0.93. What is the ratio of the Emissions(in percent) of Cote d'Ivoire in 2006 to that in 2011?
Your response must be concise. 0.96. What is the ratio of the Emissions(in percent) in Ireland in 2006 to that in 2011?
Your answer should be very brief. 0.81. What is the ratio of the Emissions(in percent) of Low income in 2007 to that in 2008?
Make the answer very short. 1.07. What is the ratio of the Emissions(in percent) in Colombia in 2007 to that in 2008?
Offer a terse response. 0.97. What is the ratio of the Emissions(in percent) in Cote d'Ivoire in 2007 to that in 2008?
Give a very brief answer. 0.95. What is the ratio of the Emissions(in percent) of Ireland in 2007 to that in 2008?
Offer a very short reply. 0.91. What is the ratio of the Emissions(in percent) in Low income in 2007 to that in 2009?
Keep it short and to the point. 0.98. What is the ratio of the Emissions(in percent) in Colombia in 2007 to that in 2009?
Make the answer very short. 0.88. What is the ratio of the Emissions(in percent) in Cote d'Ivoire in 2007 to that in 2009?
Make the answer very short. 0.88. What is the ratio of the Emissions(in percent) of Ireland in 2007 to that in 2009?
Your response must be concise. 0.9. What is the ratio of the Emissions(in percent) of Low income in 2007 to that in 2010?
Your answer should be compact. 0.85. What is the ratio of the Emissions(in percent) in Colombia in 2007 to that in 2010?
Your answer should be compact. 0.94. What is the ratio of the Emissions(in percent) of Cote d'Ivoire in 2007 to that in 2010?
Your response must be concise. 0.81. What is the ratio of the Emissions(in percent) of Ireland in 2007 to that in 2010?
Keep it short and to the point. 0.82. What is the ratio of the Emissions(in percent) of Low income in 2007 to that in 2011?
Offer a terse response. 0.83. What is the ratio of the Emissions(in percent) in Colombia in 2007 to that in 2011?
Offer a very short reply. 0.94. What is the ratio of the Emissions(in percent) in Cote d'Ivoire in 2007 to that in 2011?
Provide a short and direct response. 0.9. What is the ratio of the Emissions(in percent) of Ireland in 2007 to that in 2011?
Give a very brief answer. 0.84. What is the ratio of the Emissions(in percent) in Low income in 2008 to that in 2009?
Keep it short and to the point. 0.92. What is the ratio of the Emissions(in percent) in Colombia in 2008 to that in 2009?
Your response must be concise. 0.91. What is the ratio of the Emissions(in percent) in Cote d'Ivoire in 2008 to that in 2009?
Your answer should be compact. 0.93. What is the ratio of the Emissions(in percent) of Ireland in 2008 to that in 2009?
Offer a terse response. 0.99. What is the ratio of the Emissions(in percent) of Low income in 2008 to that in 2010?
Ensure brevity in your answer.  0.79. What is the ratio of the Emissions(in percent) in Colombia in 2008 to that in 2010?
Your answer should be compact. 0.96. What is the ratio of the Emissions(in percent) in Cote d'Ivoire in 2008 to that in 2010?
Your answer should be very brief. 0.86. What is the ratio of the Emissions(in percent) in Ireland in 2008 to that in 2010?
Give a very brief answer. 0.9. What is the ratio of the Emissions(in percent) of Low income in 2008 to that in 2011?
Make the answer very short. 0.77. What is the ratio of the Emissions(in percent) in Colombia in 2008 to that in 2011?
Your answer should be very brief. 0.97. What is the ratio of the Emissions(in percent) of Cote d'Ivoire in 2008 to that in 2011?
Offer a terse response. 0.95. What is the ratio of the Emissions(in percent) of Ireland in 2008 to that in 2011?
Give a very brief answer. 0.92. What is the ratio of the Emissions(in percent) of Low income in 2009 to that in 2010?
Offer a terse response. 0.86. What is the ratio of the Emissions(in percent) of Colombia in 2009 to that in 2010?
Your answer should be very brief. 1.06. What is the ratio of the Emissions(in percent) of Cote d'Ivoire in 2009 to that in 2010?
Your answer should be compact. 0.92. What is the ratio of the Emissions(in percent) of Ireland in 2009 to that in 2010?
Keep it short and to the point. 0.91. What is the ratio of the Emissions(in percent) in Low income in 2009 to that in 2011?
Provide a short and direct response. 0.84. What is the ratio of the Emissions(in percent) in Colombia in 2009 to that in 2011?
Provide a short and direct response. 1.07. What is the ratio of the Emissions(in percent) of Cote d'Ivoire in 2009 to that in 2011?
Provide a short and direct response. 1.02. What is the ratio of the Emissions(in percent) of Ireland in 2009 to that in 2011?
Provide a succinct answer. 0.93. What is the ratio of the Emissions(in percent) in Low income in 2010 to that in 2011?
Offer a very short reply. 0.98. What is the ratio of the Emissions(in percent) in Cote d'Ivoire in 2010 to that in 2011?
Provide a succinct answer. 1.11. What is the ratio of the Emissions(in percent) of Ireland in 2010 to that in 2011?
Offer a terse response. 1.02. What is the difference between the highest and the second highest Emissions(in percent) in Low income?
Your response must be concise. 0.03. What is the difference between the highest and the second highest Emissions(in percent) in Colombia?
Your answer should be very brief. 1.53. What is the difference between the highest and the second highest Emissions(in percent) in Cote d'Ivoire?
Provide a succinct answer. 4.06. What is the difference between the highest and the second highest Emissions(in percent) of Ireland?
Your answer should be compact. 0.63. What is the difference between the highest and the lowest Emissions(in percent) of Low income?
Make the answer very short. 0.59. What is the difference between the highest and the lowest Emissions(in percent) in Colombia?
Your answer should be very brief. 3.2. What is the difference between the highest and the lowest Emissions(in percent) of Cote d'Ivoire?
Give a very brief answer. 9.67. What is the difference between the highest and the lowest Emissions(in percent) in Ireland?
Provide a short and direct response. 8.51. 